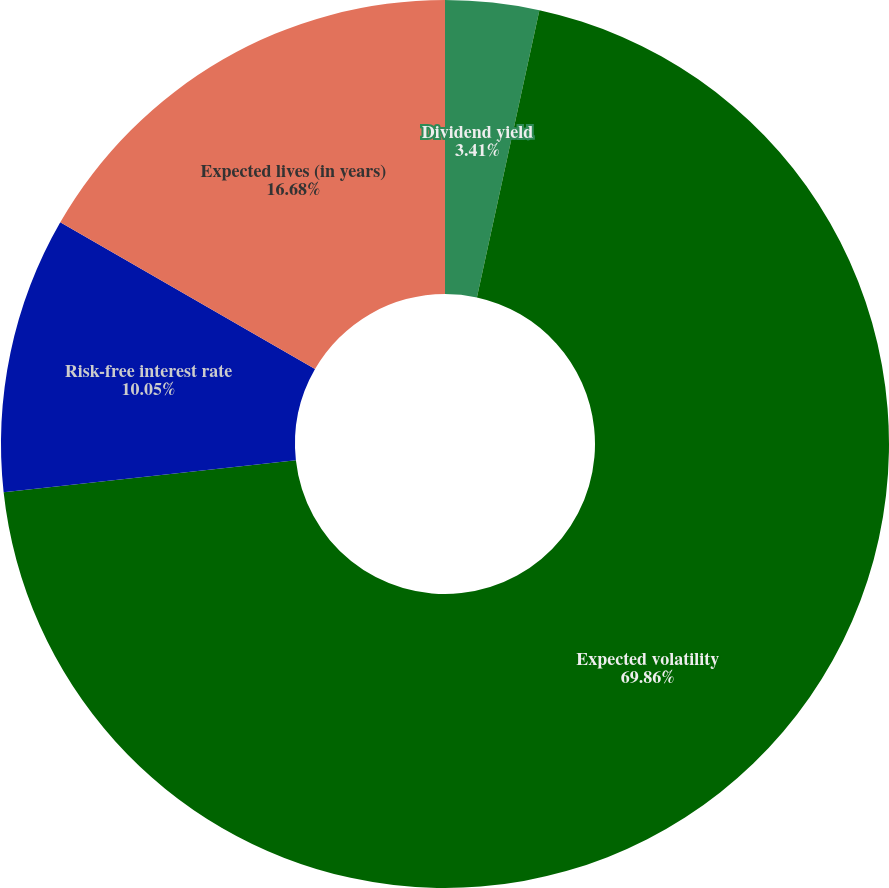<chart> <loc_0><loc_0><loc_500><loc_500><pie_chart><fcel>Dividend yield<fcel>Expected volatility<fcel>Risk-free interest rate<fcel>Expected lives (in years)<nl><fcel>3.41%<fcel>69.85%<fcel>10.05%<fcel>16.68%<nl></chart> 